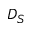Convert formula to latex. <formula><loc_0><loc_0><loc_500><loc_500>D _ { S }</formula> 